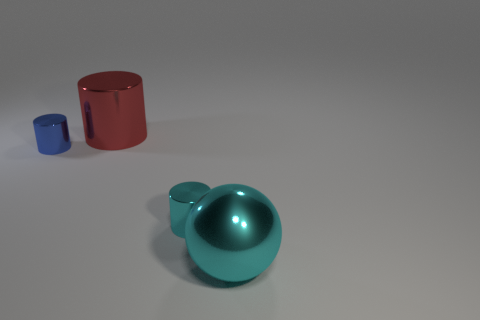Considering the shadows, where would you say the light source is located? Observing the shadows in the image, it appears that the light source is coming from the upper left side, as the shadows are cast towards the lower right. 